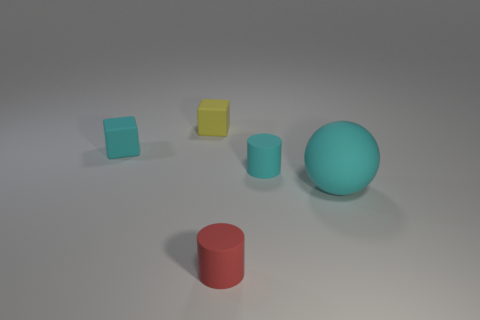Add 4 small cyan spheres. How many objects exist? 9 Subtract all green balls. Subtract all green cylinders. How many balls are left? 1 Subtract all green matte cylinders. Subtract all tiny yellow objects. How many objects are left? 4 Add 4 cyan balls. How many cyan balls are left? 5 Add 5 tiny yellow rubber things. How many tiny yellow rubber things exist? 6 Subtract 0 purple blocks. How many objects are left? 5 Subtract all spheres. How many objects are left? 4 